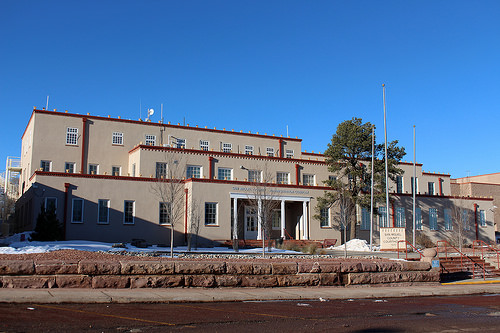<image>
Can you confirm if the sky is above the pillar? Yes. The sky is positioned above the pillar in the vertical space, higher up in the scene. 